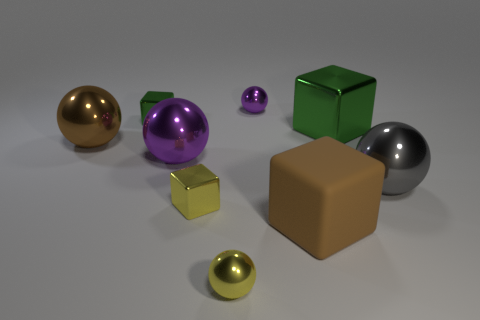Subtract all tiny yellow spheres. How many spheres are left? 4 Subtract 1 spheres. How many spheres are left? 4 Subtract all blue balls. Subtract all yellow blocks. How many balls are left? 5 Add 1 small yellow objects. How many objects exist? 10 Subtract all balls. How many objects are left? 4 Subtract all small yellow metallic blocks. Subtract all big purple spheres. How many objects are left? 7 Add 9 large brown balls. How many large brown balls are left? 10 Add 5 big green metallic things. How many big green metallic things exist? 6 Subtract 0 cyan cylinders. How many objects are left? 9 